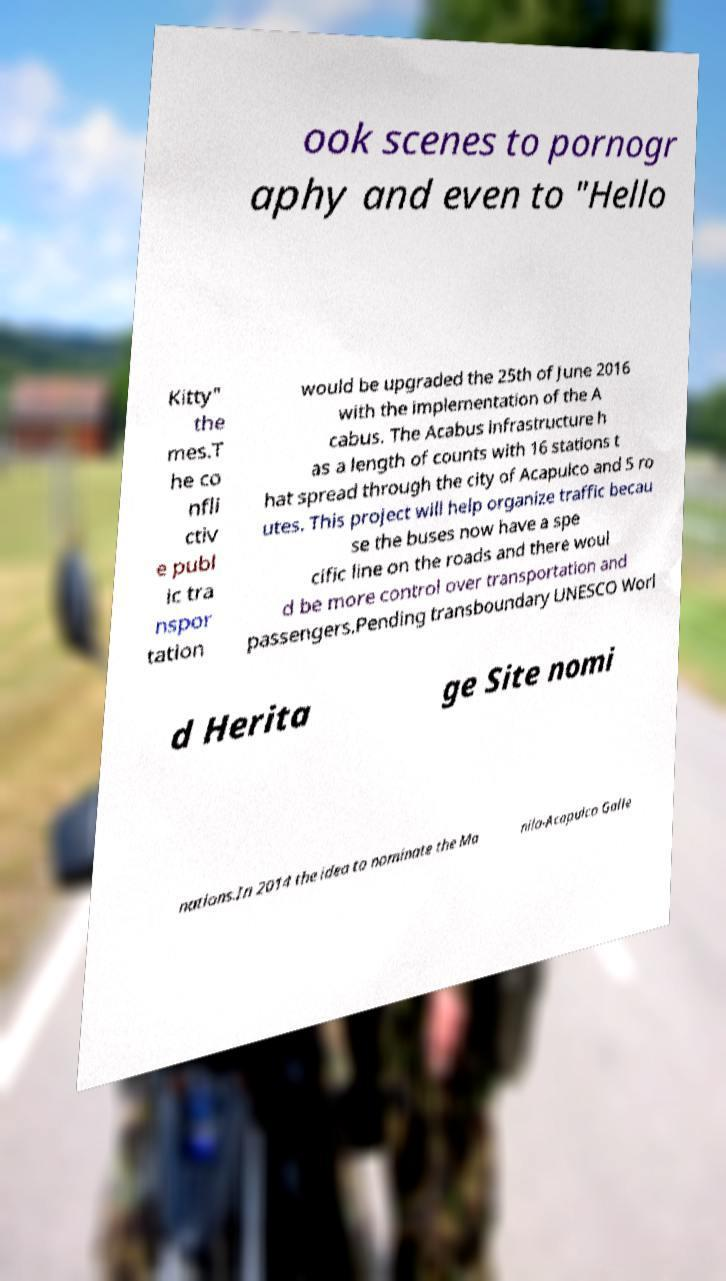There's text embedded in this image that I need extracted. Can you transcribe it verbatim? ook scenes to pornogr aphy and even to "Hello Kitty" the mes.T he co nfli ctiv e publ ic tra nspor tation would be upgraded the 25th of June 2016 with the implementation of the A cabus. The Acabus infrastructure h as a length of counts with 16 stations t hat spread through the city of Acapulco and 5 ro utes. This project will help organize traffic becau se the buses now have a spe cific line on the roads and there woul d be more control over transportation and passengers.Pending transboundary UNESCO Worl d Herita ge Site nomi nations.In 2014 the idea to nominate the Ma nila-Acapulco Galle 